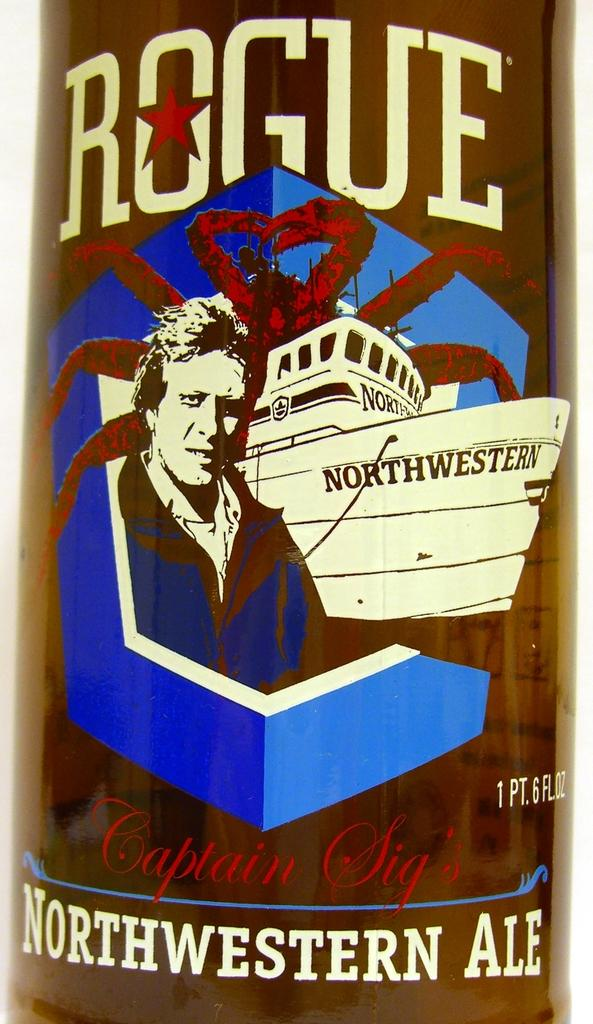What is present in the image? There is a poster in the image. What can be seen on the poster? The poster contains an image and text. What company is mentioned in the poster's text? There is no company mentioned in the poster's text, as the facts provided do not give any information about the content of the text. 